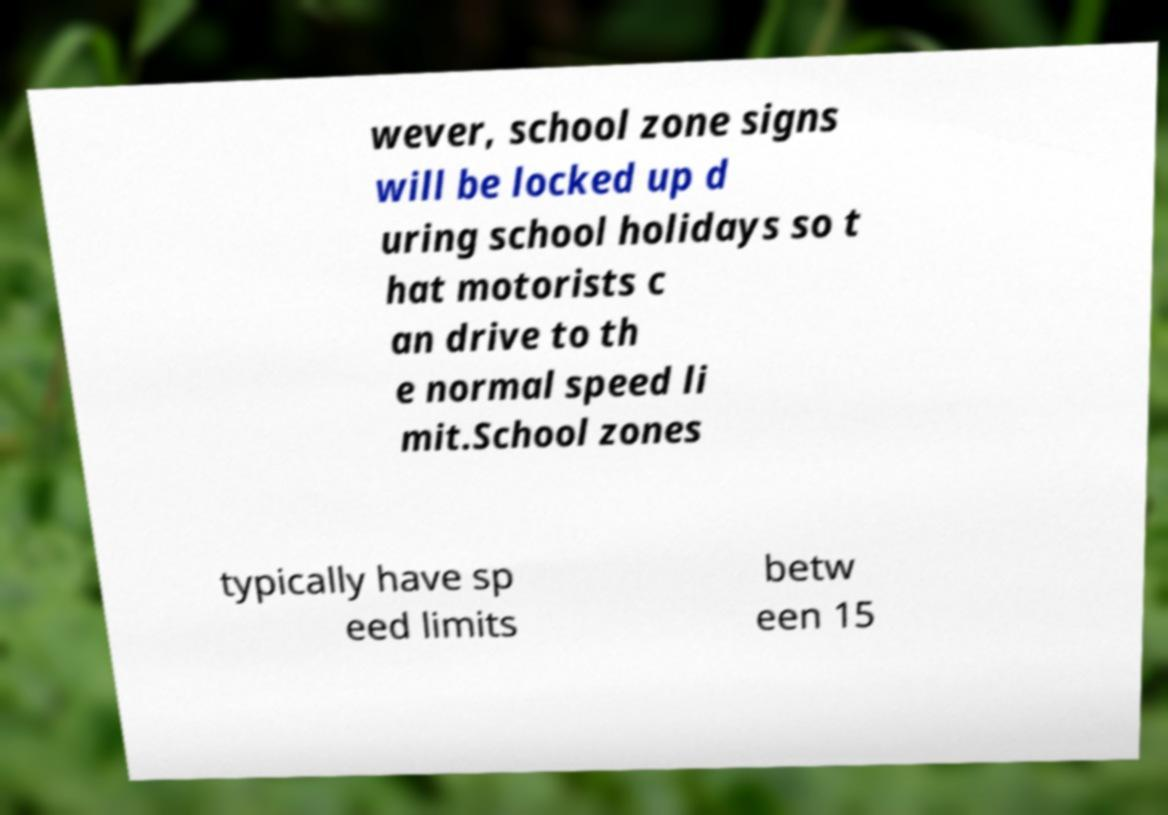Could you assist in decoding the text presented in this image and type it out clearly? wever, school zone signs will be locked up d uring school holidays so t hat motorists c an drive to th e normal speed li mit.School zones typically have sp eed limits betw een 15 